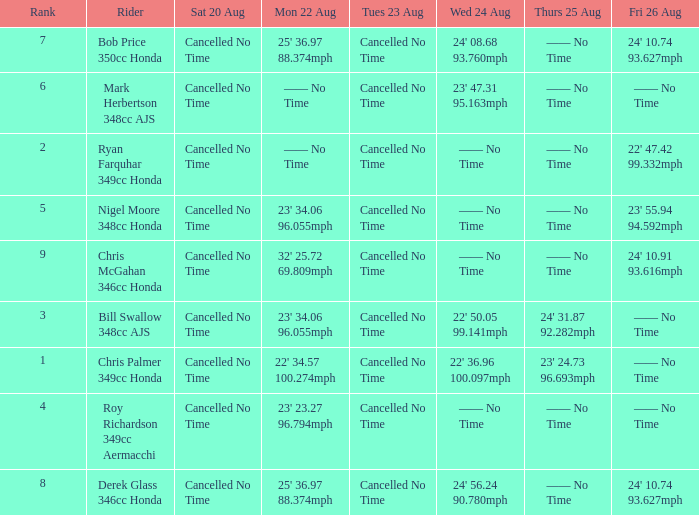I'm looking to parse the entire table for insights. Could you assist me with that? {'header': ['Rank', 'Rider', 'Sat 20 Aug', 'Mon 22 Aug', 'Tues 23 Aug', 'Wed 24 Aug', 'Thurs 25 Aug', 'Fri 26 Aug'], 'rows': [['7', 'Bob Price 350cc Honda', 'Cancelled No Time', "25' 36.97 88.374mph", 'Cancelled No Time', "24' 08.68 93.760mph", '—— No Time', "24' 10.74 93.627mph"], ['6', 'Mark Herbertson 348cc AJS', 'Cancelled No Time', '—— No Time', 'Cancelled No Time', "23' 47.31 95.163mph", '—— No Time', '—— No Time'], ['2', 'Ryan Farquhar 349cc Honda', 'Cancelled No Time', '—— No Time', 'Cancelled No Time', '—— No Time', '—— No Time', "22' 47.42 99.332mph"], ['5', 'Nigel Moore 348cc Honda', 'Cancelled No Time', "23' 34.06 96.055mph", 'Cancelled No Time', '—— No Time', '—— No Time', "23' 55.94 94.592mph"], ['9', 'Chris McGahan 346cc Honda', 'Cancelled No Time', "32' 25.72 69.809mph", 'Cancelled No Time', '—— No Time', '—— No Time', "24' 10.91 93.616mph"], ['3', 'Bill Swallow 348cc AJS', 'Cancelled No Time', "23' 34.06 96.055mph", 'Cancelled No Time', "22' 50.05 99.141mph", "24' 31.87 92.282mph", '—— No Time'], ['1', 'Chris Palmer 349cc Honda', 'Cancelled No Time', "22' 34.57 100.274mph", 'Cancelled No Time', "22' 36.96 100.097mph", "23' 24.73 96.693mph", '—— No Time'], ['4', 'Roy Richardson 349cc Aermacchi', 'Cancelled No Time', "23' 23.27 96.794mph", 'Cancelled No Time', '—— No Time', '—— No Time', '—— No Time'], ['8', 'Derek Glass 346cc Honda', 'Cancelled No Time', "25' 36.97 88.374mph", 'Cancelled No Time', "24' 56.24 90.780mph", '—— No Time', "24' 10.74 93.627mph"]]} What is every entry on Monday August 22 when the entry for Wednesday August 24 is 22' 50.05 99.141mph? 23' 34.06 96.055mph. 